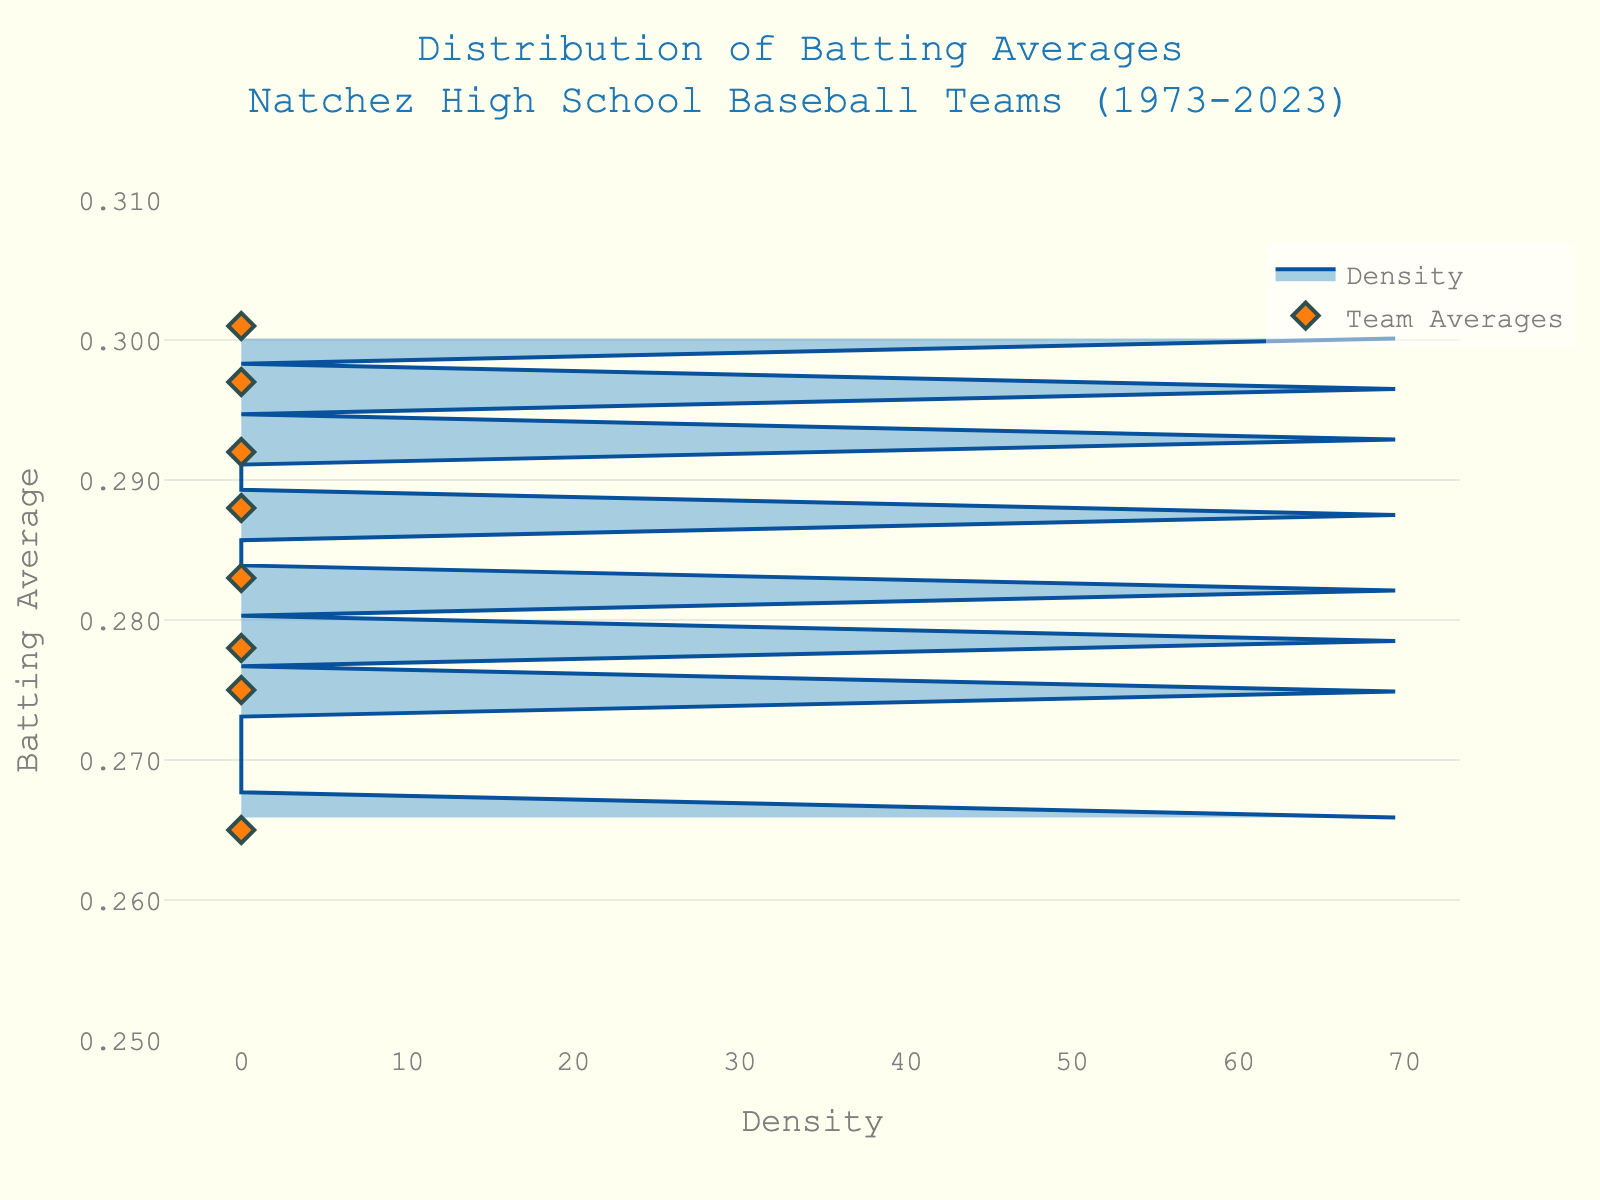Which team had the highest batting average in 2002? The density plot shows individual data points marked for each year. Locate the year 2002 and find the corresponding batting average.
Answer: Natchez High Bulldogs What's the range of batting averages displayed in the plot? Identify the lowest and highest batting averages in the data points shown in the figure.
Answer: 0.265 to 0.301 How does the batting average in 2023 compare to that in 1973? Find the data points for the years 2023 and 1973 and compare their batting averages directly.
Answer: Higher What has been the trend in batting averages from 1973 to 2023? Observe the data points across the years and note if there is an overall increase, decrease, or fluctuation in batting averages.
Answer: Increasing Which team had a batting average close to 0.283 in 1995? Locate the year 1995 on the density plot and identify the corresponding team that had a batting average of 0.283.
Answer: Adams County Christian Rebels How many teams had a batting average above 0.290? Count the number of data points that are above the 0.290 mark on the y-axis.
Answer: 3 Is the mean average batting above or below 0.290? Calculate the mean by summing all the batting averages and dividing by the number of data points, then compare this value to 0.290.
Answer: Below Was there any year where two teams had the same batting average? Examine the scatter plot for overlapping points to identify if any two batting averages coincide.
Answer: No Which year had the lowest batting average, and what was it? Identify the data point corresponding to the lowest value on the y-axis, then find the associated year.
Answer: 1980, 0.265 Is the distribution of batting averages left-skewed, right-skewed, or symmetric? Analyze the shape of the density plot. If the plot has a longer tail to the right, it is right-skewed; to the left, left-skewed; symmetric otherwise.
Answer: Right-skewed 